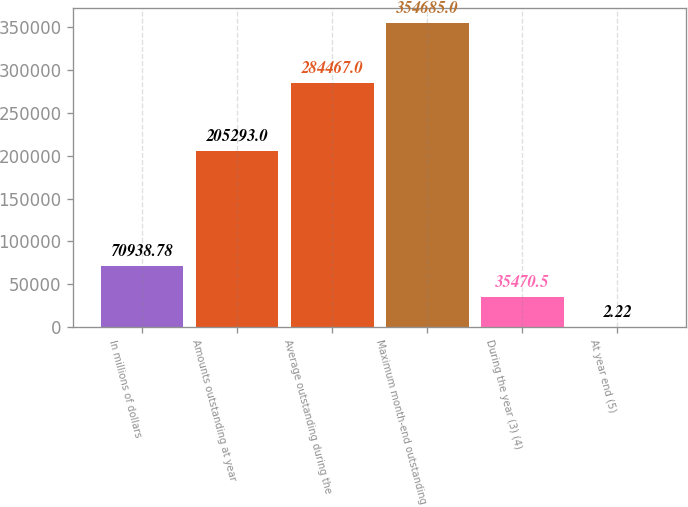Convert chart. <chart><loc_0><loc_0><loc_500><loc_500><bar_chart><fcel>In millions of dollars<fcel>Amounts outstanding at year<fcel>Average outstanding during the<fcel>Maximum month-end outstanding<fcel>During the year (3) (4)<fcel>At year end (5)<nl><fcel>70938.8<fcel>205293<fcel>284467<fcel>354685<fcel>35470.5<fcel>2.22<nl></chart> 